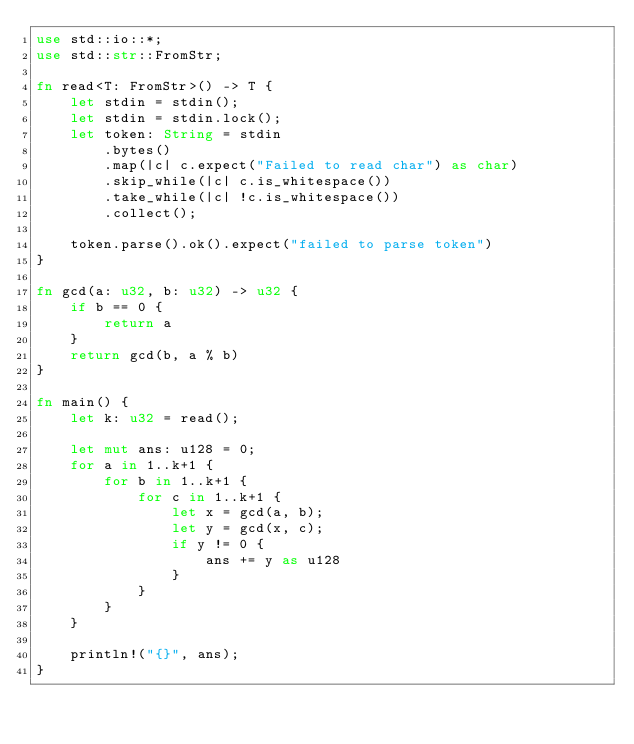Convert code to text. <code><loc_0><loc_0><loc_500><loc_500><_Rust_>use std::io::*;
use std::str::FromStr;

fn read<T: FromStr>() -> T {
    let stdin = stdin();
    let stdin = stdin.lock();
    let token: String = stdin
        .bytes()
        .map(|c| c.expect("Failed to read char") as char)
        .skip_while(|c| c.is_whitespace())
        .take_while(|c| !c.is_whitespace())
        .collect();

    token.parse().ok().expect("failed to parse token")
}

fn gcd(a: u32, b: u32) -> u32 {
    if b == 0 {
        return a
    }
    return gcd(b, a % b)
}

fn main() {
    let k: u32 = read();

    let mut ans: u128 = 0;
    for a in 1..k+1 {
        for b in 1..k+1 {
            for c in 1..k+1 {
                let x = gcd(a, b);
                let y = gcd(x, c);
                if y != 0 {
                    ans += y as u128
                }
            }
        }
    }

    println!("{}", ans);
}</code> 